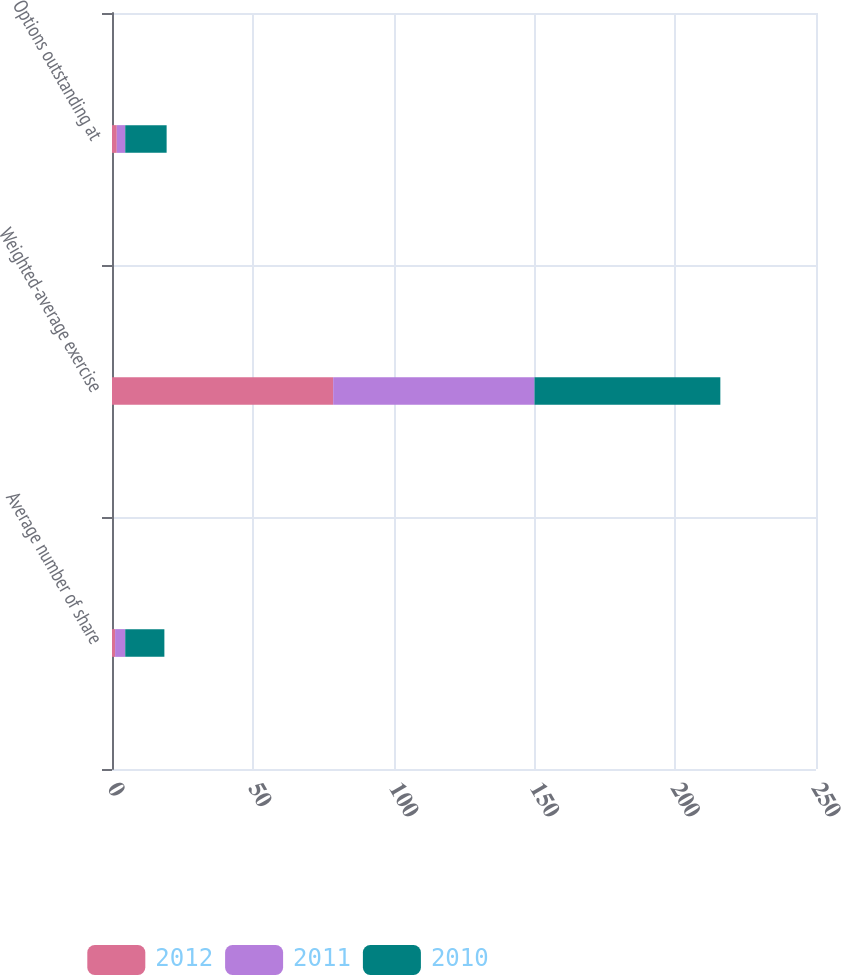Convert chart to OTSL. <chart><loc_0><loc_0><loc_500><loc_500><stacked_bar_chart><ecel><fcel>Average number of share<fcel>Weighted-average exercise<fcel>Options outstanding at<nl><fcel>2012<fcel>1.1<fcel>78.54<fcel>1.7<nl><fcel>2011<fcel>3.6<fcel>71.49<fcel>3<nl><fcel>2010<fcel>13.9<fcel>66<fcel>14.7<nl></chart> 